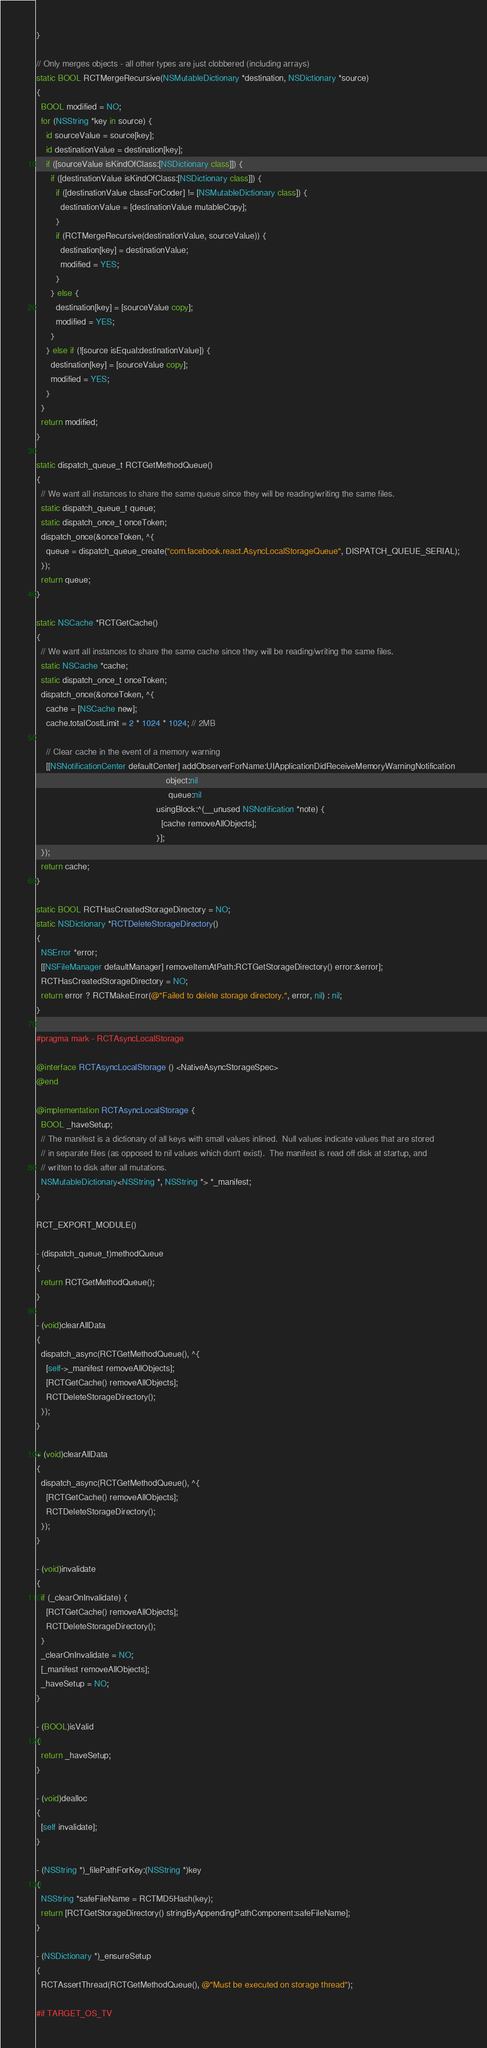Convert code to text. <code><loc_0><loc_0><loc_500><loc_500><_ObjectiveC_>}

// Only merges objects - all other types are just clobbered (including arrays)
static BOOL RCTMergeRecursive(NSMutableDictionary *destination, NSDictionary *source)
{
  BOOL modified = NO;
  for (NSString *key in source) {
    id sourceValue = source[key];
    id destinationValue = destination[key];
    if ([sourceValue isKindOfClass:[NSDictionary class]]) {
      if ([destinationValue isKindOfClass:[NSDictionary class]]) {
        if ([destinationValue classForCoder] != [NSMutableDictionary class]) {
          destinationValue = [destinationValue mutableCopy];
        }
        if (RCTMergeRecursive(destinationValue, sourceValue)) {
          destination[key] = destinationValue;
          modified = YES;
        }
      } else {
        destination[key] = [sourceValue copy];
        modified = YES;
      }
    } else if (![source isEqual:destinationValue]) {
      destination[key] = [sourceValue copy];
      modified = YES;
    }
  }
  return modified;
}

static dispatch_queue_t RCTGetMethodQueue()
{
  // We want all instances to share the same queue since they will be reading/writing the same files.
  static dispatch_queue_t queue;
  static dispatch_once_t onceToken;
  dispatch_once(&onceToken, ^{
    queue = dispatch_queue_create("com.facebook.react.AsyncLocalStorageQueue", DISPATCH_QUEUE_SERIAL);
  });
  return queue;
}

static NSCache *RCTGetCache()
{
  // We want all instances to share the same cache since they will be reading/writing the same files.
  static NSCache *cache;
  static dispatch_once_t onceToken;
  dispatch_once(&onceToken, ^{
    cache = [NSCache new];
    cache.totalCostLimit = 2 * 1024 * 1024; // 2MB

    // Clear cache in the event of a memory warning
    [[NSNotificationCenter defaultCenter] addObserverForName:UIApplicationDidReceiveMemoryWarningNotification
                                                      object:nil
                                                       queue:nil
                                                  usingBlock:^(__unused NSNotification *note) {
                                                    [cache removeAllObjects];
                                                  }];
  });
  return cache;
}

static BOOL RCTHasCreatedStorageDirectory = NO;
static NSDictionary *RCTDeleteStorageDirectory()
{
  NSError *error;
  [[NSFileManager defaultManager] removeItemAtPath:RCTGetStorageDirectory() error:&error];
  RCTHasCreatedStorageDirectory = NO;
  return error ? RCTMakeError(@"Failed to delete storage directory.", error, nil) : nil;
}

#pragma mark - RCTAsyncLocalStorage

@interface RCTAsyncLocalStorage () <NativeAsyncStorageSpec>
@end

@implementation RCTAsyncLocalStorage {
  BOOL _haveSetup;
  // The manifest is a dictionary of all keys with small values inlined.  Null values indicate values that are stored
  // in separate files (as opposed to nil values which don't exist).  The manifest is read off disk at startup, and
  // written to disk after all mutations.
  NSMutableDictionary<NSString *, NSString *> *_manifest;
}

RCT_EXPORT_MODULE()

- (dispatch_queue_t)methodQueue
{
  return RCTGetMethodQueue();
}

- (void)clearAllData
{
  dispatch_async(RCTGetMethodQueue(), ^{
    [self->_manifest removeAllObjects];
    [RCTGetCache() removeAllObjects];
    RCTDeleteStorageDirectory();
  });
}

+ (void)clearAllData
{
  dispatch_async(RCTGetMethodQueue(), ^{
    [RCTGetCache() removeAllObjects];
    RCTDeleteStorageDirectory();
  });
}

- (void)invalidate
{
  if (_clearOnInvalidate) {
    [RCTGetCache() removeAllObjects];
    RCTDeleteStorageDirectory();
  }
  _clearOnInvalidate = NO;
  [_manifest removeAllObjects];
  _haveSetup = NO;
}

- (BOOL)isValid
{
  return _haveSetup;
}

- (void)dealloc
{
  [self invalidate];
}

- (NSString *)_filePathForKey:(NSString *)key
{
  NSString *safeFileName = RCTMD5Hash(key);
  return [RCTGetStorageDirectory() stringByAppendingPathComponent:safeFileName];
}

- (NSDictionary *)_ensureSetup
{
  RCTAssertThread(RCTGetMethodQueue(), @"Must be executed on storage thread");

#if TARGET_OS_TV</code> 